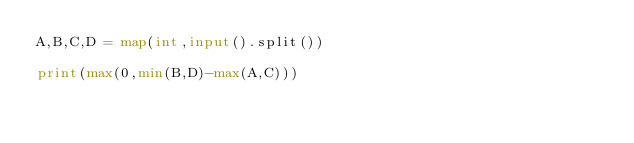<code> <loc_0><loc_0><loc_500><loc_500><_Python_>A,B,C,D = map(int,input().split())

print(max(0,min(B,D)-max(A,C)))</code> 